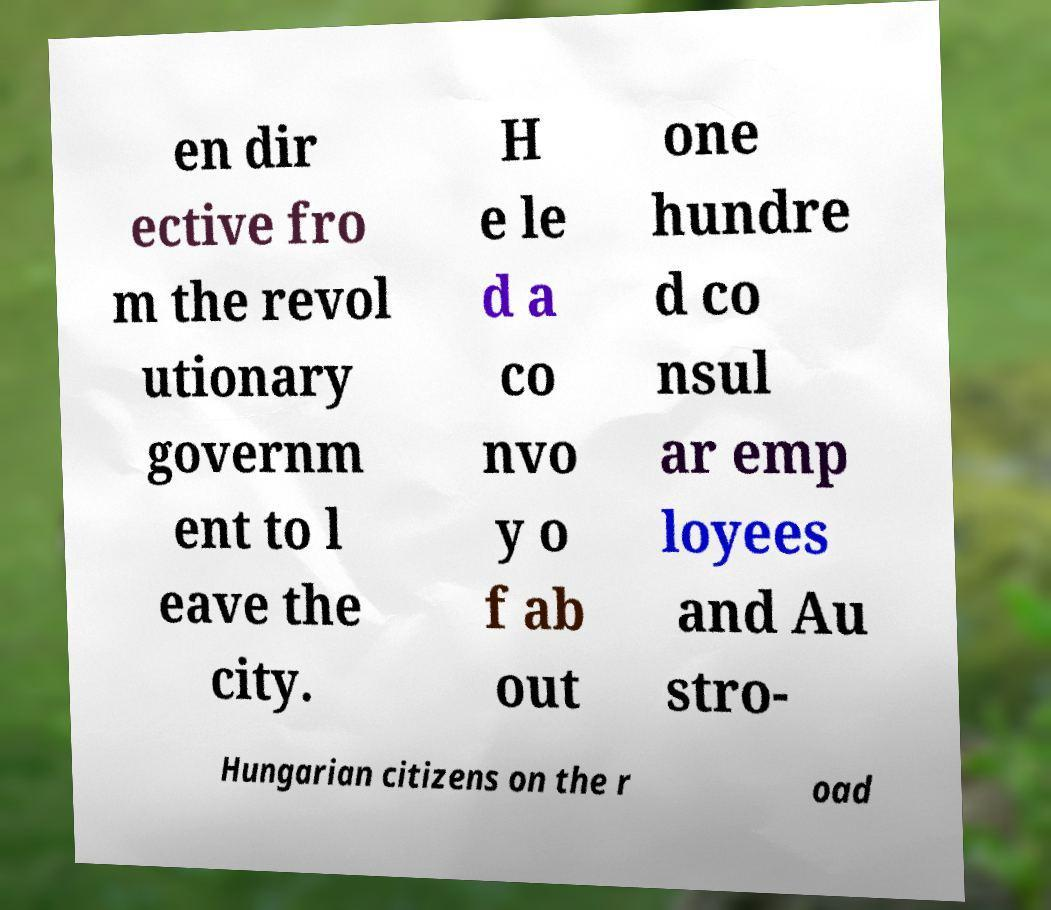Can you accurately transcribe the text from the provided image for me? en dir ective fro m the revol utionary governm ent to l eave the city. H e le d a co nvo y o f ab out one hundre d co nsul ar emp loyees and Au stro- Hungarian citizens on the r oad 